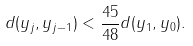Convert formula to latex. <formula><loc_0><loc_0><loc_500><loc_500>d ( y _ { j } , y _ { j - 1 } ) < \frac { 4 5 } { 4 8 } d ( y _ { 1 } , y _ { 0 } ) .</formula> 